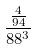<formula> <loc_0><loc_0><loc_500><loc_500>\frac { \frac { 4 } { 9 4 } } { 8 8 ^ { 3 } }</formula> 